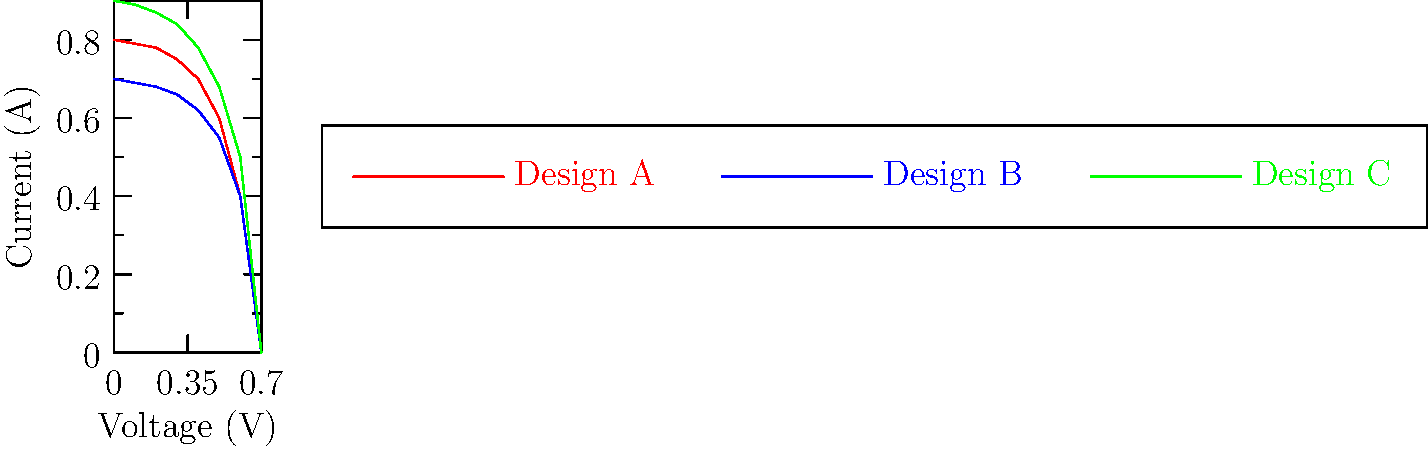As a critic skeptical of medical research publication practices, you've been asked to evaluate a study comparing solar cell designs. The researchers claim Design C is the most efficient based on the I-V curves shown. Given your expertise in critically analyzing research methodologies, what potential flaw in the researchers' conclusion should be highlighted? To critically evaluate the researchers' claim, we need to consider several factors:

1. Efficiency definition: Solar cell efficiency is typically defined as the ratio of maximum power output to incident light power, not just the highest current or voltage.

2. Maximum power point: The efficiency is determined by the maximum power point (MPP) on the I-V curve, which is the point where the product of current and voltage is highest.

3. Analysis of the curves:
   - Design A: Has a higher open-circuit voltage but lower short-circuit current.
   - Design B: Has the lowest overall performance.
   - Design C: Has the highest short-circuit current but a lower open-circuit voltage.

4. Calculation of maximum power:
   - We need to find the point on each curve where $P = I \times V$ is maximum.
   - Without exact values, it's difficult to determine this precisely from the graph.

5. Critical analysis:
   - The researchers may have incorrectly focused on just the short-circuit current, which is highest for Design C.
   - They might have overlooked the importance of the maximum power point.
   - The study may lack a clear methodology for determining efficiency from these curves.

6. Additional considerations:
   - The study doesn't provide information on the incident light power, which is crucial for efficiency calculations.
   - There's no mention of experimental conditions or repeatability of results.

7. Conclusion:
   The main flaw in the researchers' conclusion is likely an oversimplification of efficiency, possibly equating higher short-circuit current with higher efficiency without considering the maximum power point.
Answer: Oversimplification of efficiency by likely focusing on short-circuit current instead of maximum power point. 